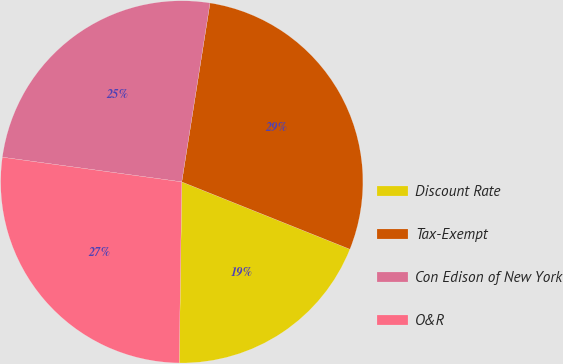<chart> <loc_0><loc_0><loc_500><loc_500><pie_chart><fcel>Discount Rate<fcel>Tax-Exempt<fcel>Con Edison of New York<fcel>O&R<nl><fcel>19.16%<fcel>28.57%<fcel>25.32%<fcel>26.95%<nl></chart> 